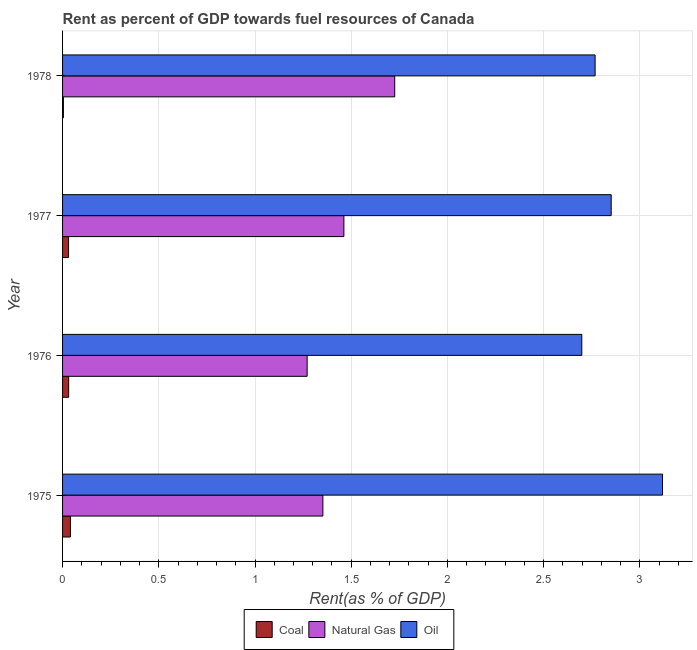Are the number of bars on each tick of the Y-axis equal?
Your response must be concise. Yes. How many bars are there on the 4th tick from the bottom?
Make the answer very short. 3. What is the label of the 4th group of bars from the top?
Provide a short and direct response. 1975. In how many cases, is the number of bars for a given year not equal to the number of legend labels?
Your response must be concise. 0. What is the rent towards coal in 1978?
Your answer should be compact. 0. Across all years, what is the maximum rent towards natural gas?
Provide a succinct answer. 1.73. Across all years, what is the minimum rent towards oil?
Keep it short and to the point. 2.7. In which year was the rent towards coal maximum?
Your response must be concise. 1975. In which year was the rent towards oil minimum?
Your answer should be compact. 1976. What is the total rent towards oil in the graph?
Provide a short and direct response. 11.43. What is the difference between the rent towards coal in 1975 and that in 1978?
Keep it short and to the point. 0.04. What is the difference between the rent towards oil in 1977 and the rent towards natural gas in 1978?
Provide a short and direct response. 1.12. What is the average rent towards coal per year?
Make the answer very short. 0.03. In the year 1975, what is the difference between the rent towards oil and rent towards natural gas?
Make the answer very short. 1.76. In how many years, is the rent towards oil greater than 2.6 %?
Give a very brief answer. 4. What is the ratio of the rent towards coal in 1975 to that in 1977?
Provide a succinct answer. 1.31. Is the difference between the rent towards natural gas in 1977 and 1978 greater than the difference between the rent towards oil in 1977 and 1978?
Make the answer very short. No. What is the difference between the highest and the second highest rent towards coal?
Keep it short and to the point. 0.01. Is the sum of the rent towards coal in 1977 and 1978 greater than the maximum rent towards natural gas across all years?
Your response must be concise. No. What does the 2nd bar from the top in 1976 represents?
Provide a short and direct response. Natural Gas. What does the 2nd bar from the bottom in 1975 represents?
Give a very brief answer. Natural Gas. How many bars are there?
Provide a short and direct response. 12. Are all the bars in the graph horizontal?
Provide a short and direct response. Yes. How many years are there in the graph?
Give a very brief answer. 4. Where does the legend appear in the graph?
Your answer should be very brief. Bottom center. How are the legend labels stacked?
Give a very brief answer. Horizontal. What is the title of the graph?
Offer a terse response. Rent as percent of GDP towards fuel resources of Canada. Does "ICT services" appear as one of the legend labels in the graph?
Offer a terse response. No. What is the label or title of the X-axis?
Give a very brief answer. Rent(as % of GDP). What is the label or title of the Y-axis?
Your answer should be very brief. Year. What is the Rent(as % of GDP) in Coal in 1975?
Ensure brevity in your answer.  0.04. What is the Rent(as % of GDP) in Natural Gas in 1975?
Your answer should be very brief. 1.35. What is the Rent(as % of GDP) of Oil in 1975?
Provide a short and direct response. 3.12. What is the Rent(as % of GDP) of Coal in 1976?
Keep it short and to the point. 0.03. What is the Rent(as % of GDP) in Natural Gas in 1976?
Ensure brevity in your answer.  1.27. What is the Rent(as % of GDP) in Oil in 1976?
Your response must be concise. 2.7. What is the Rent(as % of GDP) in Coal in 1977?
Your response must be concise. 0.03. What is the Rent(as % of GDP) of Natural Gas in 1977?
Make the answer very short. 1.46. What is the Rent(as % of GDP) of Oil in 1977?
Make the answer very short. 2.85. What is the Rent(as % of GDP) of Coal in 1978?
Your answer should be very brief. 0. What is the Rent(as % of GDP) of Natural Gas in 1978?
Provide a succinct answer. 1.73. What is the Rent(as % of GDP) in Oil in 1978?
Keep it short and to the point. 2.77. Across all years, what is the maximum Rent(as % of GDP) in Coal?
Make the answer very short. 0.04. Across all years, what is the maximum Rent(as % of GDP) of Natural Gas?
Keep it short and to the point. 1.73. Across all years, what is the maximum Rent(as % of GDP) of Oil?
Offer a very short reply. 3.12. Across all years, what is the minimum Rent(as % of GDP) of Coal?
Provide a short and direct response. 0. Across all years, what is the minimum Rent(as % of GDP) of Natural Gas?
Provide a succinct answer. 1.27. Across all years, what is the minimum Rent(as % of GDP) in Oil?
Ensure brevity in your answer.  2.7. What is the total Rent(as % of GDP) of Coal in the graph?
Keep it short and to the point. 0.11. What is the total Rent(as % of GDP) of Natural Gas in the graph?
Your response must be concise. 5.81. What is the total Rent(as % of GDP) of Oil in the graph?
Provide a short and direct response. 11.43. What is the difference between the Rent(as % of GDP) of Coal in 1975 and that in 1976?
Provide a short and direct response. 0.01. What is the difference between the Rent(as % of GDP) in Natural Gas in 1975 and that in 1976?
Offer a terse response. 0.08. What is the difference between the Rent(as % of GDP) of Oil in 1975 and that in 1976?
Give a very brief answer. 0.42. What is the difference between the Rent(as % of GDP) in Coal in 1975 and that in 1977?
Keep it short and to the point. 0.01. What is the difference between the Rent(as % of GDP) in Natural Gas in 1975 and that in 1977?
Offer a terse response. -0.11. What is the difference between the Rent(as % of GDP) in Oil in 1975 and that in 1977?
Your answer should be compact. 0.27. What is the difference between the Rent(as % of GDP) in Coal in 1975 and that in 1978?
Offer a terse response. 0.04. What is the difference between the Rent(as % of GDP) of Natural Gas in 1975 and that in 1978?
Your response must be concise. -0.37. What is the difference between the Rent(as % of GDP) of Oil in 1975 and that in 1978?
Ensure brevity in your answer.  0.35. What is the difference between the Rent(as % of GDP) in Coal in 1976 and that in 1977?
Your response must be concise. 0. What is the difference between the Rent(as % of GDP) in Natural Gas in 1976 and that in 1977?
Offer a terse response. -0.19. What is the difference between the Rent(as % of GDP) in Oil in 1976 and that in 1977?
Provide a succinct answer. -0.15. What is the difference between the Rent(as % of GDP) of Coal in 1976 and that in 1978?
Offer a very short reply. 0.03. What is the difference between the Rent(as % of GDP) of Natural Gas in 1976 and that in 1978?
Your response must be concise. -0.46. What is the difference between the Rent(as % of GDP) in Oil in 1976 and that in 1978?
Keep it short and to the point. -0.07. What is the difference between the Rent(as % of GDP) of Coal in 1977 and that in 1978?
Your response must be concise. 0.03. What is the difference between the Rent(as % of GDP) in Natural Gas in 1977 and that in 1978?
Make the answer very short. -0.26. What is the difference between the Rent(as % of GDP) of Oil in 1977 and that in 1978?
Your response must be concise. 0.08. What is the difference between the Rent(as % of GDP) in Coal in 1975 and the Rent(as % of GDP) in Natural Gas in 1976?
Give a very brief answer. -1.23. What is the difference between the Rent(as % of GDP) of Coal in 1975 and the Rent(as % of GDP) of Oil in 1976?
Provide a short and direct response. -2.66. What is the difference between the Rent(as % of GDP) in Natural Gas in 1975 and the Rent(as % of GDP) in Oil in 1976?
Offer a terse response. -1.35. What is the difference between the Rent(as % of GDP) in Coal in 1975 and the Rent(as % of GDP) in Natural Gas in 1977?
Provide a succinct answer. -1.42. What is the difference between the Rent(as % of GDP) in Coal in 1975 and the Rent(as % of GDP) in Oil in 1977?
Your response must be concise. -2.81. What is the difference between the Rent(as % of GDP) in Natural Gas in 1975 and the Rent(as % of GDP) in Oil in 1977?
Provide a short and direct response. -1.5. What is the difference between the Rent(as % of GDP) of Coal in 1975 and the Rent(as % of GDP) of Natural Gas in 1978?
Give a very brief answer. -1.69. What is the difference between the Rent(as % of GDP) of Coal in 1975 and the Rent(as % of GDP) of Oil in 1978?
Your answer should be compact. -2.73. What is the difference between the Rent(as % of GDP) in Natural Gas in 1975 and the Rent(as % of GDP) in Oil in 1978?
Provide a succinct answer. -1.41. What is the difference between the Rent(as % of GDP) of Coal in 1976 and the Rent(as % of GDP) of Natural Gas in 1977?
Provide a short and direct response. -1.43. What is the difference between the Rent(as % of GDP) in Coal in 1976 and the Rent(as % of GDP) in Oil in 1977?
Ensure brevity in your answer.  -2.82. What is the difference between the Rent(as % of GDP) in Natural Gas in 1976 and the Rent(as % of GDP) in Oil in 1977?
Your answer should be compact. -1.58. What is the difference between the Rent(as % of GDP) in Coal in 1976 and the Rent(as % of GDP) in Natural Gas in 1978?
Ensure brevity in your answer.  -1.69. What is the difference between the Rent(as % of GDP) in Coal in 1976 and the Rent(as % of GDP) in Oil in 1978?
Your answer should be very brief. -2.74. What is the difference between the Rent(as % of GDP) in Natural Gas in 1976 and the Rent(as % of GDP) in Oil in 1978?
Provide a short and direct response. -1.5. What is the difference between the Rent(as % of GDP) in Coal in 1977 and the Rent(as % of GDP) in Natural Gas in 1978?
Your answer should be compact. -1.69. What is the difference between the Rent(as % of GDP) in Coal in 1977 and the Rent(as % of GDP) in Oil in 1978?
Your answer should be compact. -2.74. What is the difference between the Rent(as % of GDP) in Natural Gas in 1977 and the Rent(as % of GDP) in Oil in 1978?
Your answer should be compact. -1.31. What is the average Rent(as % of GDP) of Coal per year?
Your answer should be very brief. 0.03. What is the average Rent(as % of GDP) of Natural Gas per year?
Your response must be concise. 1.45. What is the average Rent(as % of GDP) in Oil per year?
Provide a succinct answer. 2.86. In the year 1975, what is the difference between the Rent(as % of GDP) of Coal and Rent(as % of GDP) of Natural Gas?
Your response must be concise. -1.31. In the year 1975, what is the difference between the Rent(as % of GDP) of Coal and Rent(as % of GDP) of Oil?
Provide a succinct answer. -3.08. In the year 1975, what is the difference between the Rent(as % of GDP) of Natural Gas and Rent(as % of GDP) of Oil?
Ensure brevity in your answer.  -1.76. In the year 1976, what is the difference between the Rent(as % of GDP) of Coal and Rent(as % of GDP) of Natural Gas?
Ensure brevity in your answer.  -1.24. In the year 1976, what is the difference between the Rent(as % of GDP) of Coal and Rent(as % of GDP) of Oil?
Your response must be concise. -2.67. In the year 1976, what is the difference between the Rent(as % of GDP) of Natural Gas and Rent(as % of GDP) of Oil?
Provide a short and direct response. -1.43. In the year 1977, what is the difference between the Rent(as % of GDP) of Coal and Rent(as % of GDP) of Natural Gas?
Offer a very short reply. -1.43. In the year 1977, what is the difference between the Rent(as % of GDP) of Coal and Rent(as % of GDP) of Oil?
Provide a short and direct response. -2.82. In the year 1977, what is the difference between the Rent(as % of GDP) of Natural Gas and Rent(as % of GDP) of Oil?
Your answer should be very brief. -1.39. In the year 1978, what is the difference between the Rent(as % of GDP) in Coal and Rent(as % of GDP) in Natural Gas?
Keep it short and to the point. -1.72. In the year 1978, what is the difference between the Rent(as % of GDP) in Coal and Rent(as % of GDP) in Oil?
Your response must be concise. -2.76. In the year 1978, what is the difference between the Rent(as % of GDP) in Natural Gas and Rent(as % of GDP) in Oil?
Give a very brief answer. -1.04. What is the ratio of the Rent(as % of GDP) in Coal in 1975 to that in 1976?
Provide a short and direct response. 1.29. What is the ratio of the Rent(as % of GDP) of Natural Gas in 1975 to that in 1976?
Provide a short and direct response. 1.06. What is the ratio of the Rent(as % of GDP) in Oil in 1975 to that in 1976?
Provide a succinct answer. 1.16. What is the ratio of the Rent(as % of GDP) in Coal in 1975 to that in 1977?
Offer a terse response. 1.31. What is the ratio of the Rent(as % of GDP) of Natural Gas in 1975 to that in 1977?
Offer a terse response. 0.93. What is the ratio of the Rent(as % of GDP) of Oil in 1975 to that in 1977?
Offer a terse response. 1.09. What is the ratio of the Rent(as % of GDP) of Coal in 1975 to that in 1978?
Provide a short and direct response. 9.42. What is the ratio of the Rent(as % of GDP) in Natural Gas in 1975 to that in 1978?
Your answer should be compact. 0.78. What is the ratio of the Rent(as % of GDP) of Oil in 1975 to that in 1978?
Your answer should be compact. 1.13. What is the ratio of the Rent(as % of GDP) of Coal in 1976 to that in 1977?
Offer a terse response. 1.02. What is the ratio of the Rent(as % of GDP) of Natural Gas in 1976 to that in 1977?
Your answer should be compact. 0.87. What is the ratio of the Rent(as % of GDP) in Oil in 1976 to that in 1977?
Offer a terse response. 0.95. What is the ratio of the Rent(as % of GDP) of Coal in 1976 to that in 1978?
Your response must be concise. 7.3. What is the ratio of the Rent(as % of GDP) in Natural Gas in 1976 to that in 1978?
Your response must be concise. 0.74. What is the ratio of the Rent(as % of GDP) of Oil in 1976 to that in 1978?
Keep it short and to the point. 0.97. What is the ratio of the Rent(as % of GDP) in Coal in 1977 to that in 1978?
Your answer should be compact. 7.17. What is the ratio of the Rent(as % of GDP) of Natural Gas in 1977 to that in 1978?
Offer a terse response. 0.85. What is the ratio of the Rent(as % of GDP) of Oil in 1977 to that in 1978?
Make the answer very short. 1.03. What is the difference between the highest and the second highest Rent(as % of GDP) in Coal?
Make the answer very short. 0.01. What is the difference between the highest and the second highest Rent(as % of GDP) of Natural Gas?
Make the answer very short. 0.26. What is the difference between the highest and the second highest Rent(as % of GDP) in Oil?
Keep it short and to the point. 0.27. What is the difference between the highest and the lowest Rent(as % of GDP) in Coal?
Provide a succinct answer. 0.04. What is the difference between the highest and the lowest Rent(as % of GDP) in Natural Gas?
Provide a succinct answer. 0.46. What is the difference between the highest and the lowest Rent(as % of GDP) in Oil?
Your answer should be compact. 0.42. 